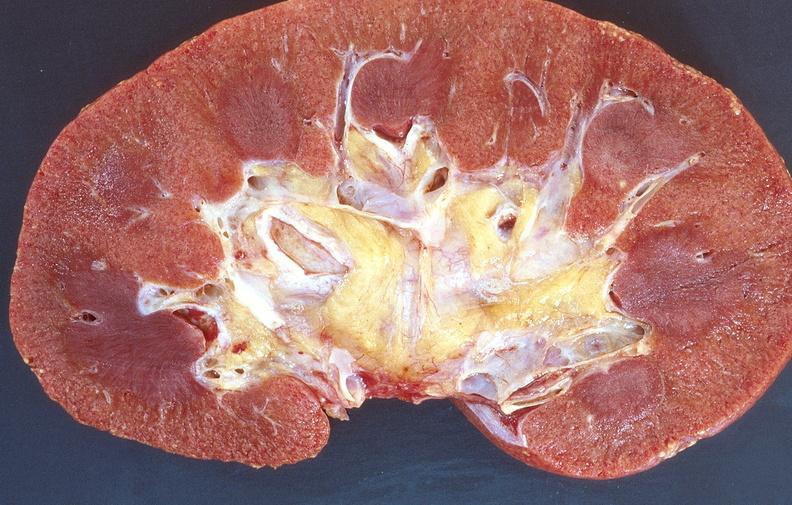does this image show normal kidney?
Answer the question using a single word or phrase. Yes 